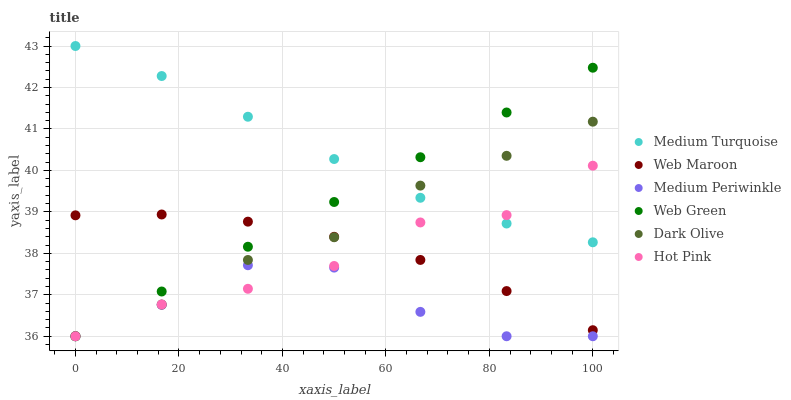Does Medium Periwinkle have the minimum area under the curve?
Answer yes or no. Yes. Does Medium Turquoise have the maximum area under the curve?
Answer yes or no. Yes. Does Web Maroon have the minimum area under the curve?
Answer yes or no. No. Does Web Maroon have the maximum area under the curve?
Answer yes or no. No. Is Web Green the smoothest?
Answer yes or no. Yes. Is Medium Periwinkle the roughest?
Answer yes or no. Yes. Is Web Maroon the smoothest?
Answer yes or no. No. Is Web Maroon the roughest?
Answer yes or no. No. Does Hot Pink have the lowest value?
Answer yes or no. Yes. Does Web Maroon have the lowest value?
Answer yes or no. No. Does Medium Turquoise have the highest value?
Answer yes or no. Yes. Does Web Maroon have the highest value?
Answer yes or no. No. Is Medium Periwinkle less than Medium Turquoise?
Answer yes or no. Yes. Is Web Maroon greater than Medium Periwinkle?
Answer yes or no. Yes. Does Hot Pink intersect Web Green?
Answer yes or no. Yes. Is Hot Pink less than Web Green?
Answer yes or no. No. Is Hot Pink greater than Web Green?
Answer yes or no. No. Does Medium Periwinkle intersect Medium Turquoise?
Answer yes or no. No. 